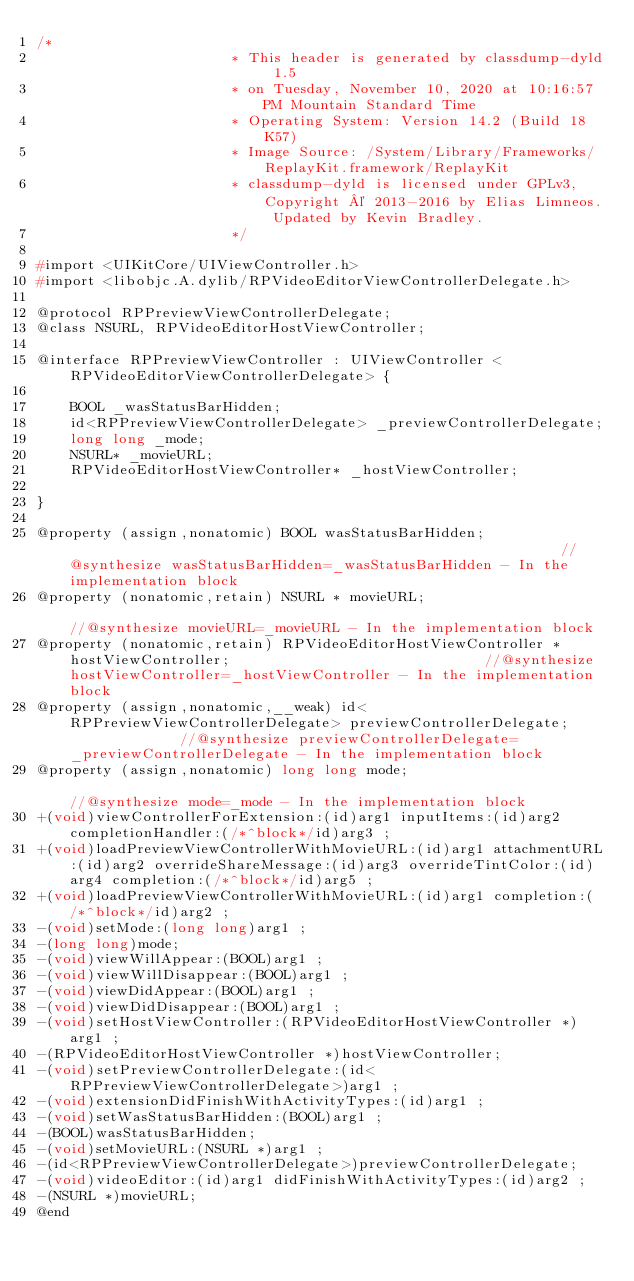Convert code to text. <code><loc_0><loc_0><loc_500><loc_500><_C_>/*
                       * This header is generated by classdump-dyld 1.5
                       * on Tuesday, November 10, 2020 at 10:16:57 PM Mountain Standard Time
                       * Operating System: Version 14.2 (Build 18K57)
                       * Image Source: /System/Library/Frameworks/ReplayKit.framework/ReplayKit
                       * classdump-dyld is licensed under GPLv3, Copyright © 2013-2016 by Elias Limneos. Updated by Kevin Bradley.
                       */

#import <UIKitCore/UIViewController.h>
#import <libobjc.A.dylib/RPVideoEditorViewControllerDelegate.h>

@protocol RPPreviewViewControllerDelegate;
@class NSURL, RPVideoEditorHostViewController;

@interface RPPreviewViewController : UIViewController <RPVideoEditorViewControllerDelegate> {

	BOOL _wasStatusBarHidden;
	id<RPPreviewViewControllerDelegate> _previewControllerDelegate;
	long long _mode;
	NSURL* _movieURL;
	RPVideoEditorHostViewController* _hostViewController;

}

@property (assign,nonatomic) BOOL wasStatusBarHidden;                                                           //@synthesize wasStatusBarHidden=_wasStatusBarHidden - In the implementation block
@property (nonatomic,retain) NSURL * movieURL;                                                                  //@synthesize movieURL=_movieURL - In the implementation block
@property (nonatomic,retain) RPVideoEditorHostViewController * hostViewController;                              //@synthesize hostViewController=_hostViewController - In the implementation block
@property (assign,nonatomic,__weak) id<RPPreviewViewControllerDelegate> previewControllerDelegate;              //@synthesize previewControllerDelegate=_previewControllerDelegate - In the implementation block
@property (assign,nonatomic) long long mode;                                                                    //@synthesize mode=_mode - In the implementation block
+(void)viewControllerForExtension:(id)arg1 inputItems:(id)arg2 completionHandler:(/*^block*/id)arg3 ;
+(void)loadPreviewViewControllerWithMovieURL:(id)arg1 attachmentURL:(id)arg2 overrideShareMessage:(id)arg3 overrideTintColor:(id)arg4 completion:(/*^block*/id)arg5 ;
+(void)loadPreviewViewControllerWithMovieURL:(id)arg1 completion:(/*^block*/id)arg2 ;
-(void)setMode:(long long)arg1 ;
-(long long)mode;
-(void)viewWillAppear:(BOOL)arg1 ;
-(void)viewWillDisappear:(BOOL)arg1 ;
-(void)viewDidAppear:(BOOL)arg1 ;
-(void)viewDidDisappear:(BOOL)arg1 ;
-(void)setHostViewController:(RPVideoEditorHostViewController *)arg1 ;
-(RPVideoEditorHostViewController *)hostViewController;
-(void)setPreviewControllerDelegate:(id<RPPreviewViewControllerDelegate>)arg1 ;
-(void)extensionDidFinishWithActivityTypes:(id)arg1 ;
-(void)setWasStatusBarHidden:(BOOL)arg1 ;
-(BOOL)wasStatusBarHidden;
-(void)setMovieURL:(NSURL *)arg1 ;
-(id<RPPreviewViewControllerDelegate>)previewControllerDelegate;
-(void)videoEditor:(id)arg1 didFinishWithActivityTypes:(id)arg2 ;
-(NSURL *)movieURL;
@end

</code> 